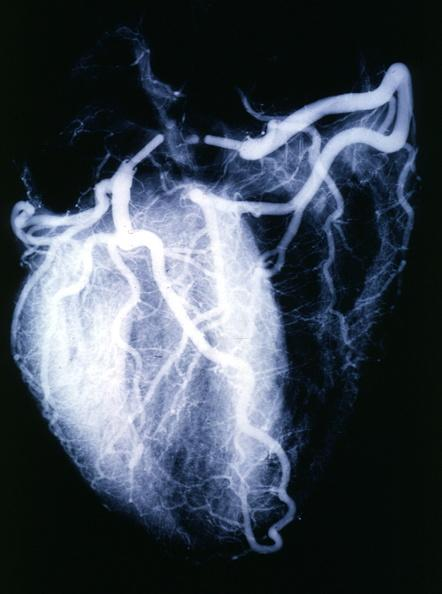does retroperitoneal leiomyosarcoma show x-ray postmortnormal coronaries?
Answer the question using a single word or phrase. No 